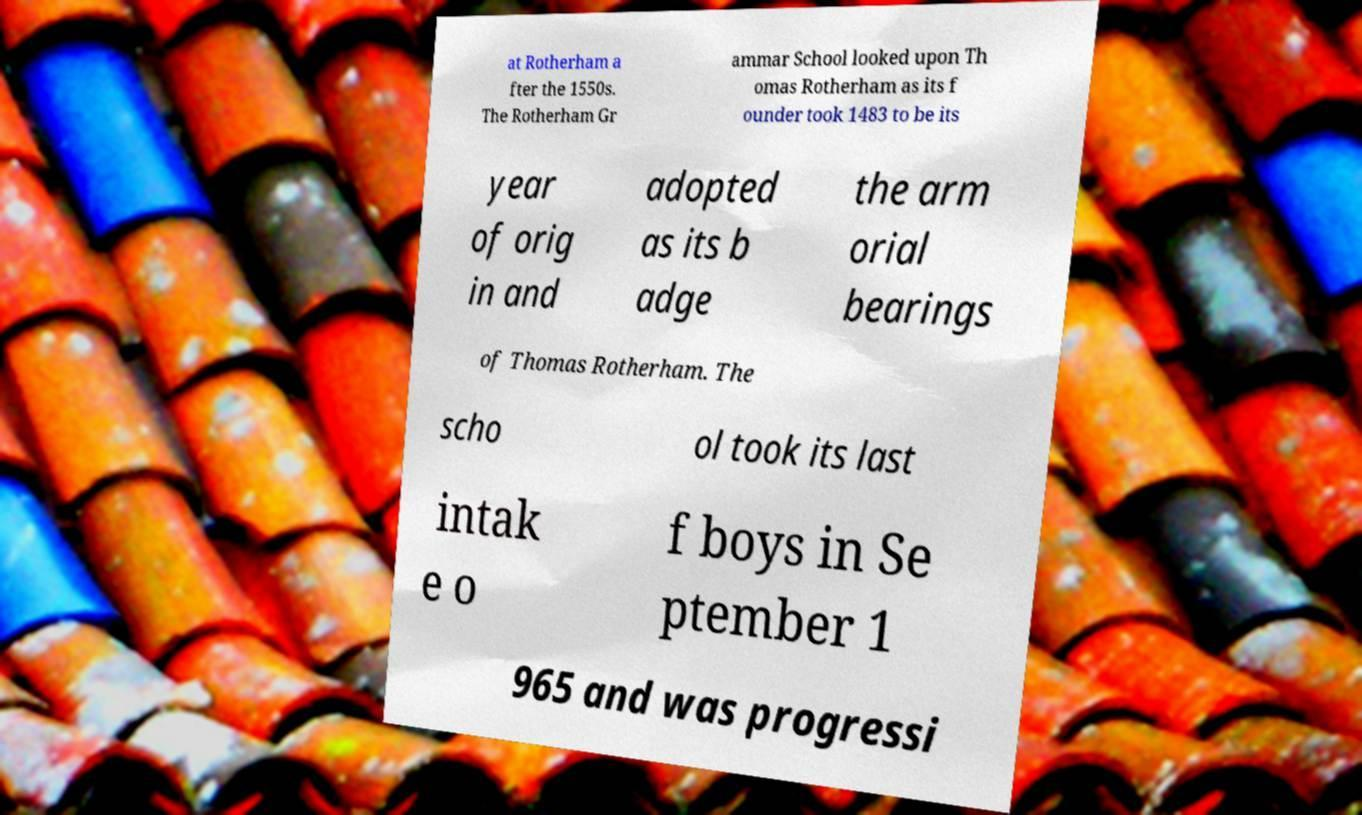Could you extract and type out the text from this image? at Rotherham a fter the 1550s. The Rotherham Gr ammar School looked upon Th omas Rotherham as its f ounder took 1483 to be its year of orig in and adopted as its b adge the arm orial bearings of Thomas Rotherham. The scho ol took its last intak e o f boys in Se ptember 1 965 and was progressi 